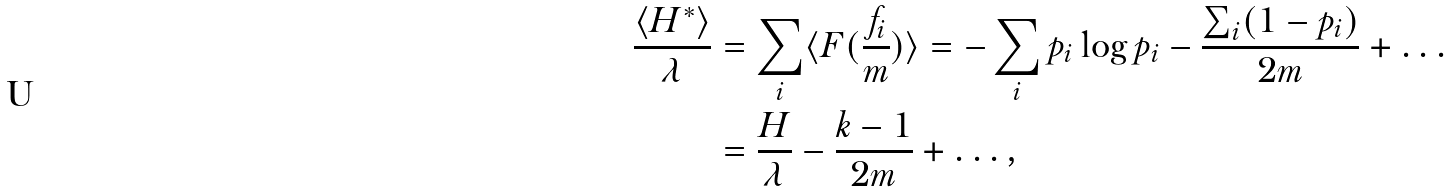Convert formula to latex. <formula><loc_0><loc_0><loc_500><loc_500>\frac { \langle H ^ { * } \rangle } { \lambda } & = \sum _ { i } \langle F ( \frac { f _ { i } } { m } ) \rangle = - \sum _ { i } p _ { i } \log p _ { i } - \frac { \sum _ { i } ( 1 - p _ { i } ) } { 2 m } + \dots \\ & = \frac { H } { \lambda } - \frac { k - 1 } { 2 m } + \dots ,</formula> 